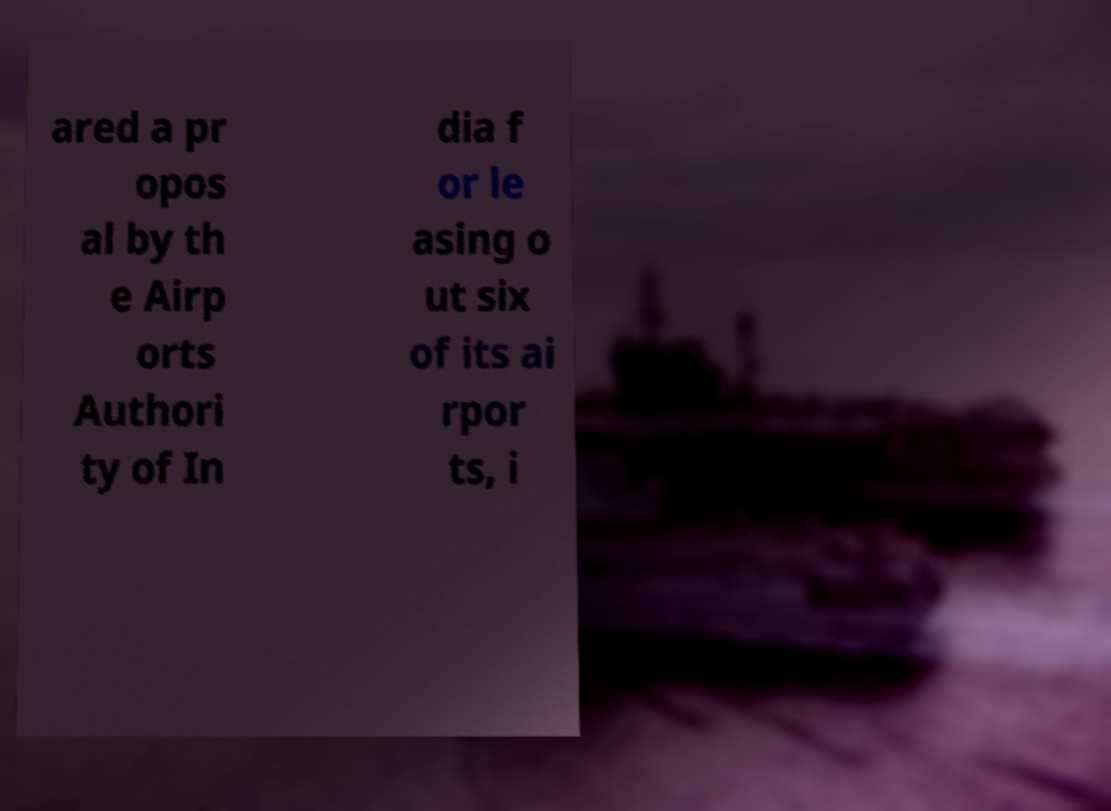Please read and relay the text visible in this image. What does it say? ared a pr opos al by th e Airp orts Authori ty of In dia f or le asing o ut six of its ai rpor ts, i 